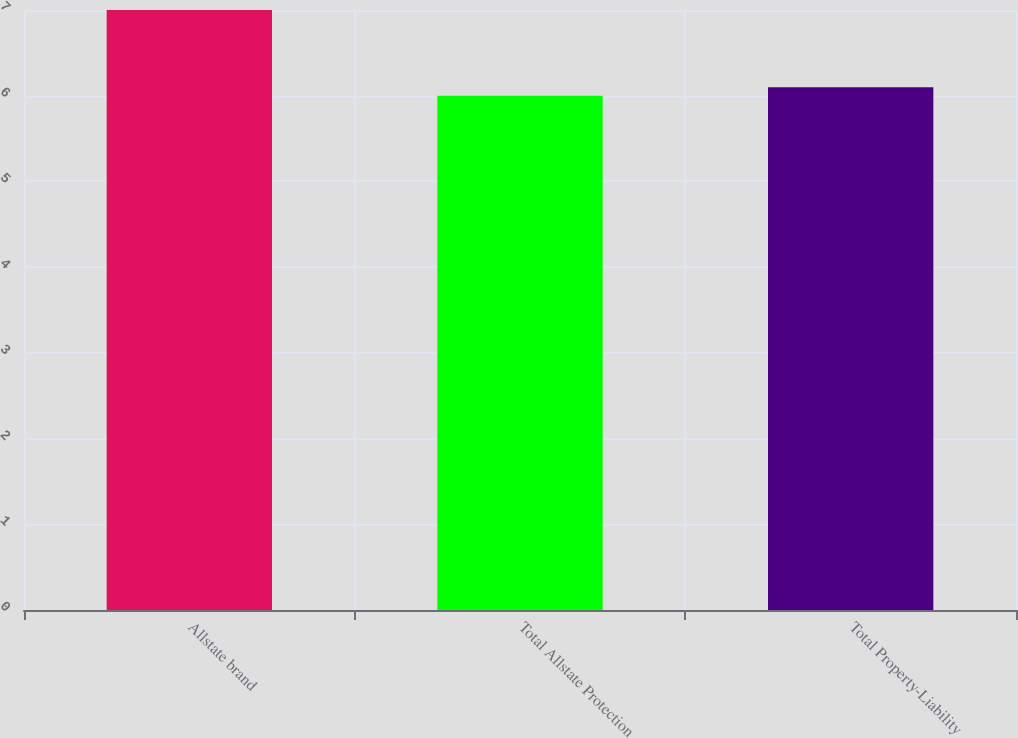Convert chart to OTSL. <chart><loc_0><loc_0><loc_500><loc_500><bar_chart><fcel>Allstate brand<fcel>Total Allstate Protection<fcel>Total Property-Liability<nl><fcel>7<fcel>6<fcel>6.1<nl></chart> 